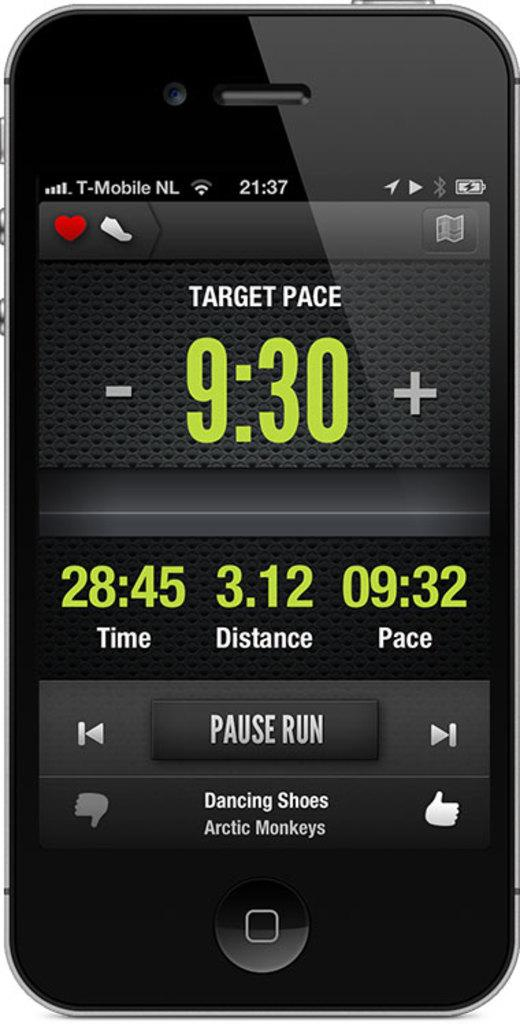<image>
Share a concise interpretation of the image provided. a phone that has the time of 9:30 on it 